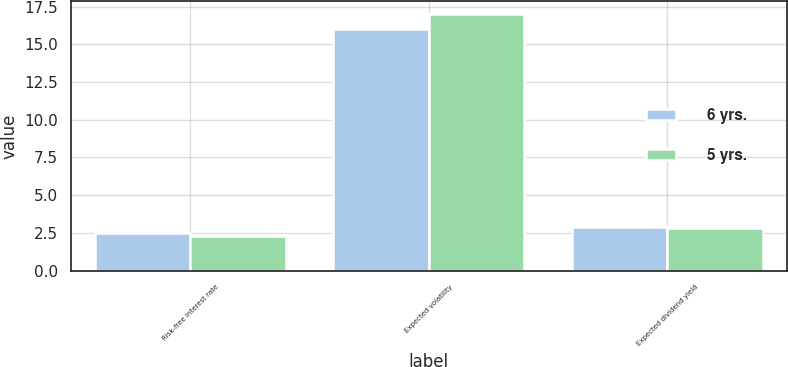Convert chart. <chart><loc_0><loc_0><loc_500><loc_500><stacked_bar_chart><ecel><fcel>Risk-free interest rate<fcel>Expected volatility<fcel>Expected dividend yield<nl><fcel>6 yrs.<fcel>2.5<fcel>16<fcel>2.9<nl><fcel>5 yrs.<fcel>2.3<fcel>17<fcel>2.8<nl></chart> 